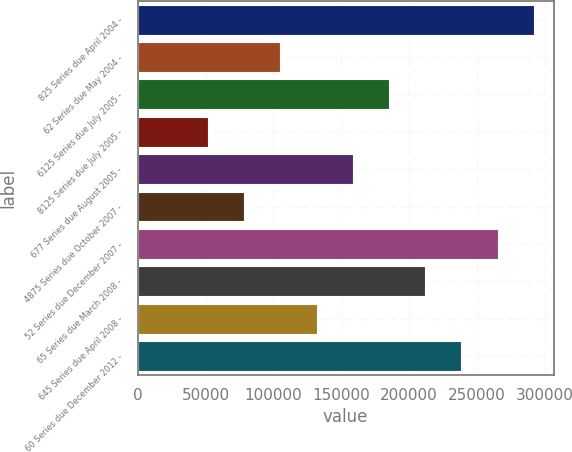Convert chart. <chart><loc_0><loc_0><loc_500><loc_500><bar_chart><fcel>825 Series due April 2004 -<fcel>62 Series due May 2004 -<fcel>6125 Series due July 2005 -<fcel>8125 Series due July 2005 -<fcel>677 Series due August 2005 -<fcel>4875 Series due October 2007 -<fcel>52 Series due December 2007 -<fcel>65 Series due March 2008 -<fcel>645 Series due April 2008 -<fcel>60 Series due December 2012 -<nl><fcel>292000<fcel>105100<fcel>185200<fcel>51700<fcel>158500<fcel>78400<fcel>265300<fcel>211900<fcel>131800<fcel>238600<nl></chart> 